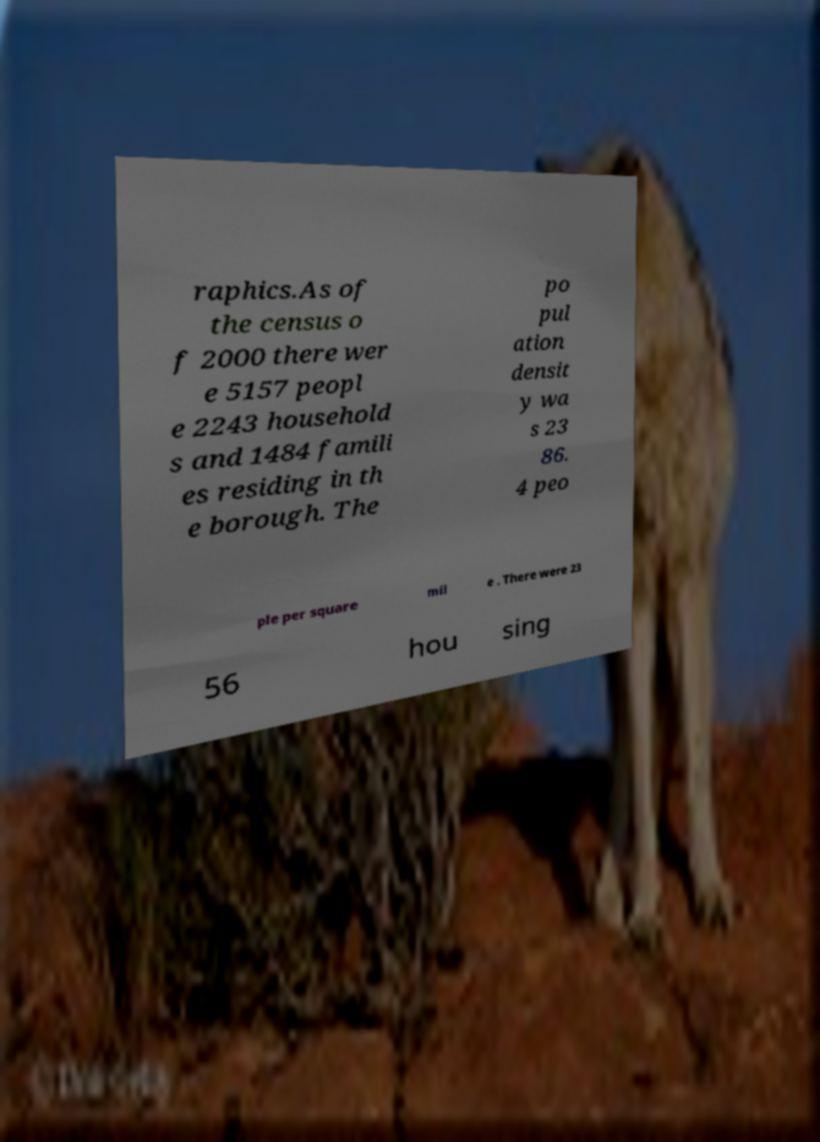Please identify and transcribe the text found in this image. raphics.As of the census o f 2000 there wer e 5157 peopl e 2243 household s and 1484 famili es residing in th e borough. The po pul ation densit y wa s 23 86. 4 peo ple per square mil e . There were 23 56 hou sing 